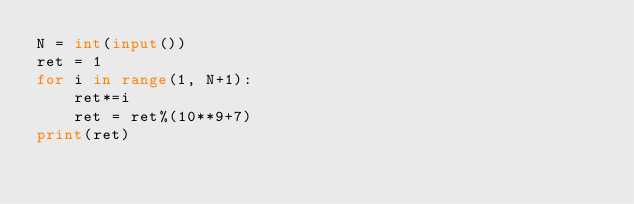Convert code to text. <code><loc_0><loc_0><loc_500><loc_500><_Python_>N = int(input())
ret = 1
for i in range(1, N+1):
    ret*=i
    ret = ret%(10**9+7)
print(ret)</code> 